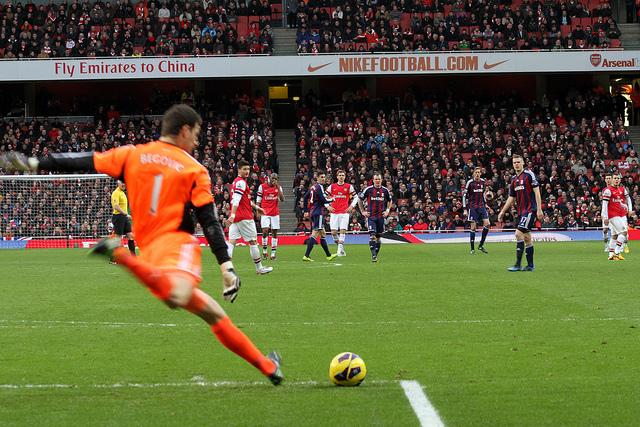What is the number of the player kicking the ball?
Quick response, please. 1. Is the ball in motion?
Keep it brief. No. What company flies to China?
Short answer required. Emirates. 